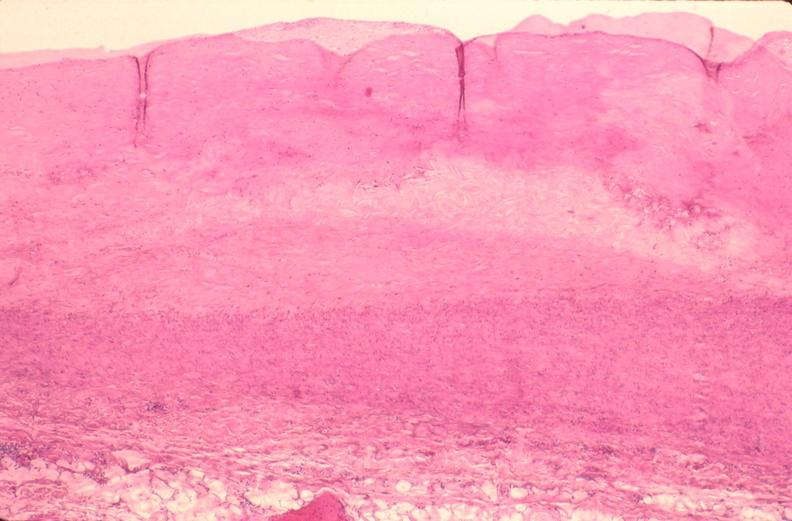does this show pulmonary artery atherosclerosis in patient with pulmonary hypertension?
Answer the question using a single word or phrase. No 